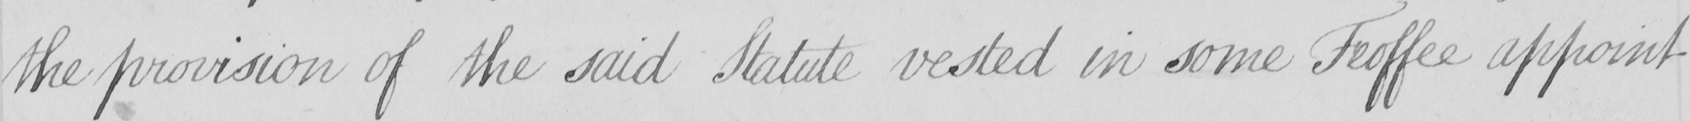Can you tell me what this handwritten text says? the provision of the said Statute vested in some Feoffee appoint 